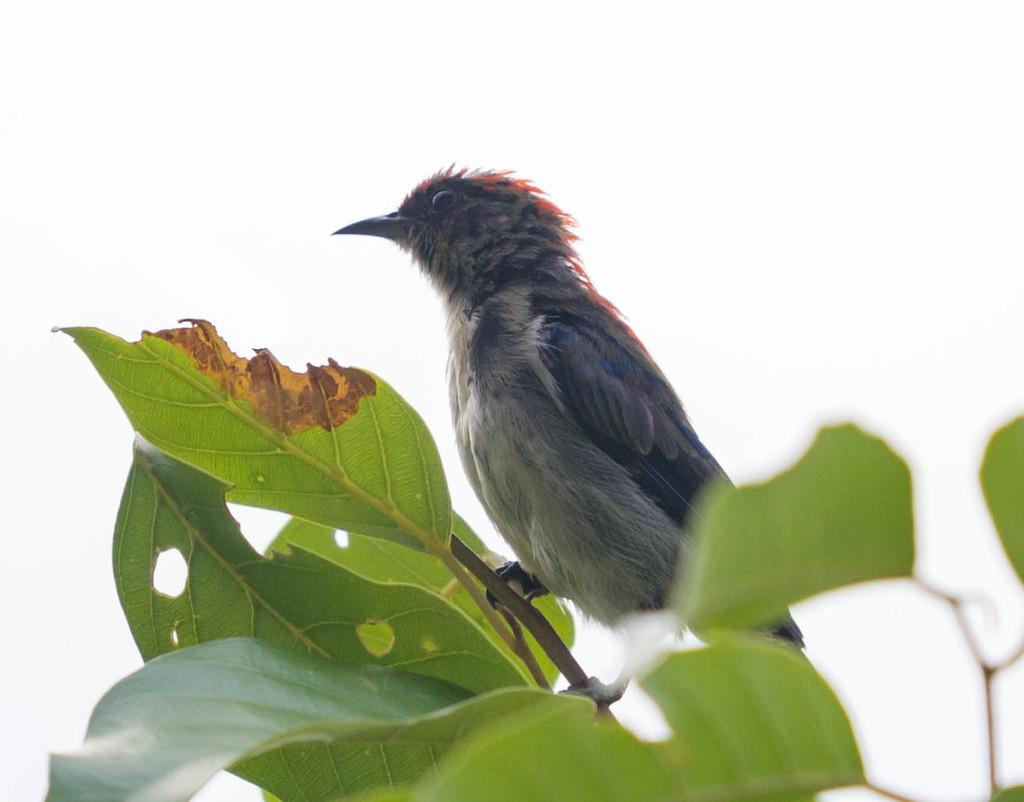What type of animal can be seen in the image? There is a bird in the image. Where is the bird located in the image? The bird is on the stem of a plant. What other parts of the plant are visible in the image? There are leaves visible in the image. What can be seen in the background of the image? The sky is visible in the background of the image. What color is the crayon being used by the bird in the image? There is no crayon present in the image, and the bird is not using any coloring tools. 